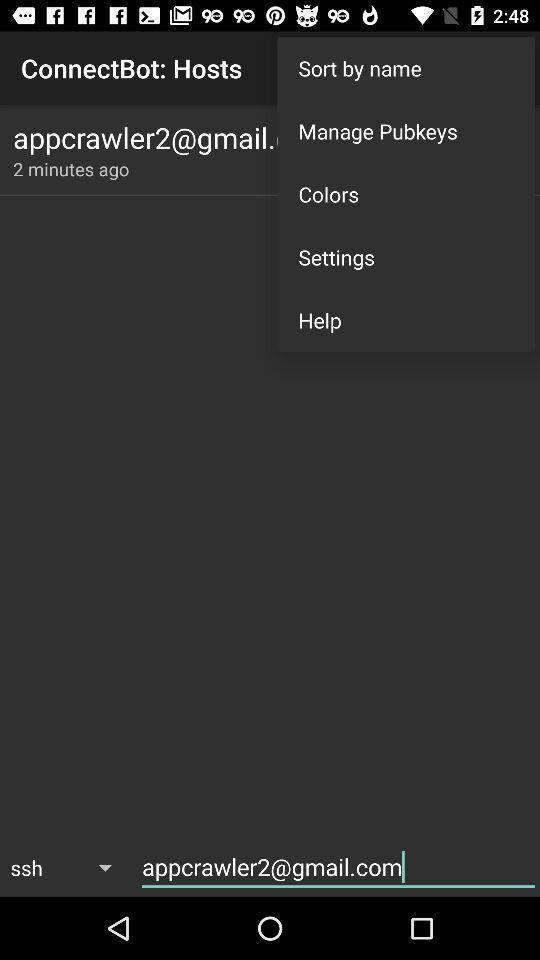What is email address? The email address is appcrawler2@gmail.com. 